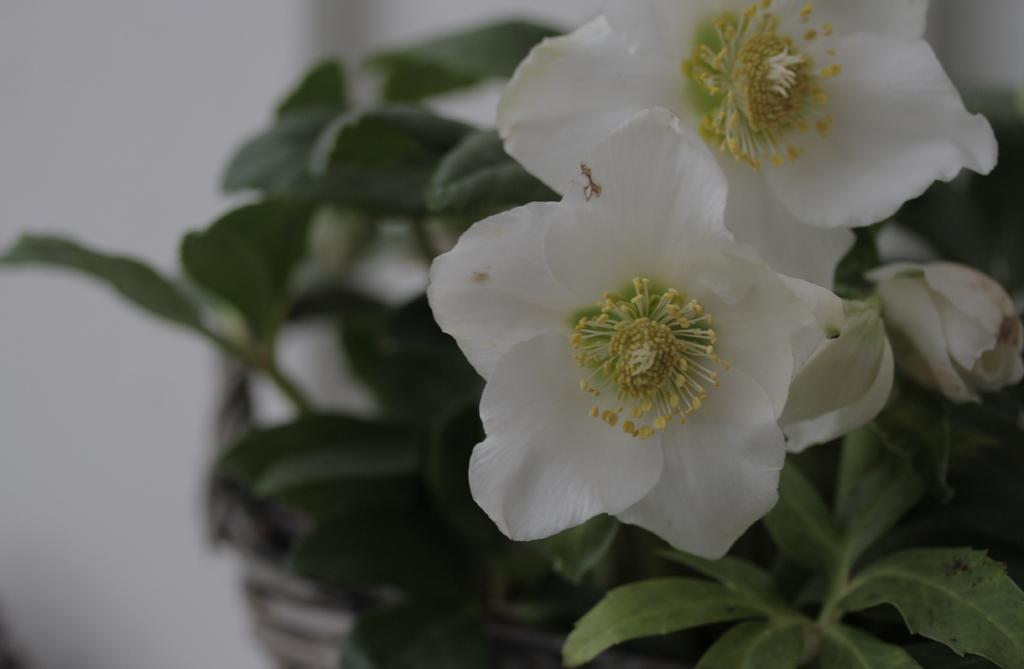What type of plants can be seen in the image? There are flowers in the image. What type of mine can be seen in the image? There is no mine present in the image; it features flowers. What is the bucket used for in the image? There is no bucket present in the image. 